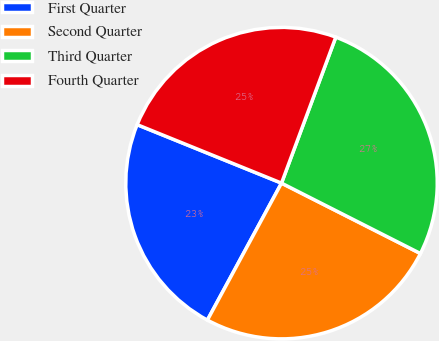Convert chart to OTSL. <chart><loc_0><loc_0><loc_500><loc_500><pie_chart><fcel>First Quarter<fcel>Second Quarter<fcel>Third Quarter<fcel>Fourth Quarter<nl><fcel>23.23%<fcel>25.43%<fcel>26.8%<fcel>24.54%<nl></chart> 